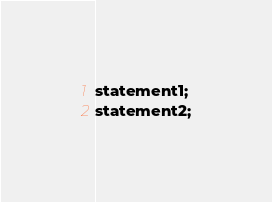<code> <loc_0><loc_0><loc_500><loc_500><_SQL_>statement1;
statement2;</code> 